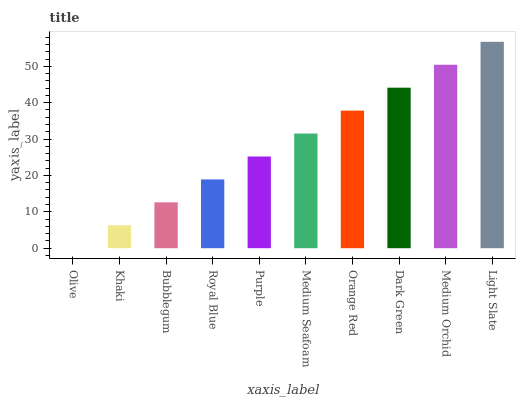Is Olive the minimum?
Answer yes or no. Yes. Is Light Slate the maximum?
Answer yes or no. Yes. Is Khaki the minimum?
Answer yes or no. No. Is Khaki the maximum?
Answer yes or no. No. Is Khaki greater than Olive?
Answer yes or no. Yes. Is Olive less than Khaki?
Answer yes or no. Yes. Is Olive greater than Khaki?
Answer yes or no. No. Is Khaki less than Olive?
Answer yes or no. No. Is Medium Seafoam the high median?
Answer yes or no. Yes. Is Purple the low median?
Answer yes or no. Yes. Is Dark Green the high median?
Answer yes or no. No. Is Khaki the low median?
Answer yes or no. No. 